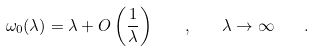Convert formula to latex. <formula><loc_0><loc_0><loc_500><loc_500>\omega _ { 0 } ( \lambda ) = \lambda + O \left ( \frac { 1 } { \lambda } \right ) \quad , \quad \lambda \rightarrow \infty \quad .</formula> 